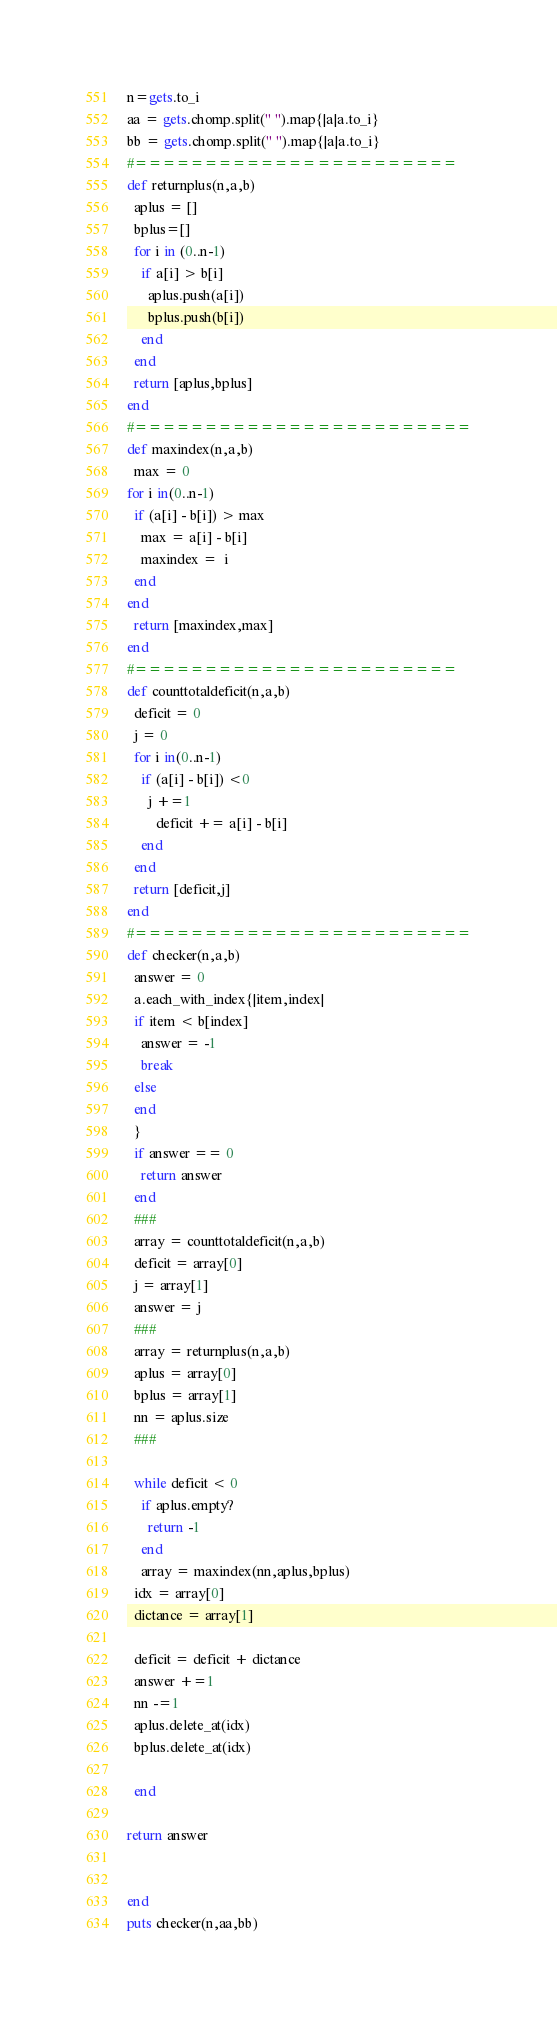<code> <loc_0><loc_0><loc_500><loc_500><_Ruby_>n=gets.to_i
aa = gets.chomp.split(" ").map{|a|a.to_i}
bb = gets.chomp.split(" ").map{|a|a.to_i}
#=======================
def returnplus(n,a,b)
  aplus = []
  bplus=[]
  for i in (0..n-1)
    if a[i] > b[i]
      aplus.push(a[i])
      bplus.push(b[i])
    end
  end
  return [aplus,bplus]
end
#========================
def maxindex(n,a,b)
  max = 0
for i in(0..n-1)
  if (a[i] - b[i]) > max
    max = a[i] - b[i]
    maxindex =  i
  end
end
  return [maxindex,max]
end
#=======================
def counttotaldeficit(n,a,b)
  deficit = 0
  j = 0
  for i in(0..n-1)
    if (a[i] - b[i]) <0
      j +=1
        deficit += a[i] - b[i]
    end
  end
  return [deficit,j]
end
#========================
def checker(n,a,b)
  answer = 0
  a.each_with_index{|item,index|
  if item < b[index]
    answer = -1
    break
  else
  end
  }
  if answer == 0
    return answer
  end
  ###
  array = counttotaldeficit(n,a,b)
  deficit = array[0]
  j = array[1]
  answer = j
  ###
  array = returnplus(n,a,b)
  aplus = array[0]
  bplus = array[1]
  nn = aplus.size
  ###

  while deficit < 0
    if aplus.empty?
      return -1
    end
    array = maxindex(nn,aplus,bplus)
  idx = array[0]
  dictance = array[1]

  deficit = deficit + dictance
  answer +=1
  nn -=1
  aplus.delete_at(idx)
  bplus.delete_at(idx)
  
  end

return answer


end
puts checker(n,aa,bb)
</code> 